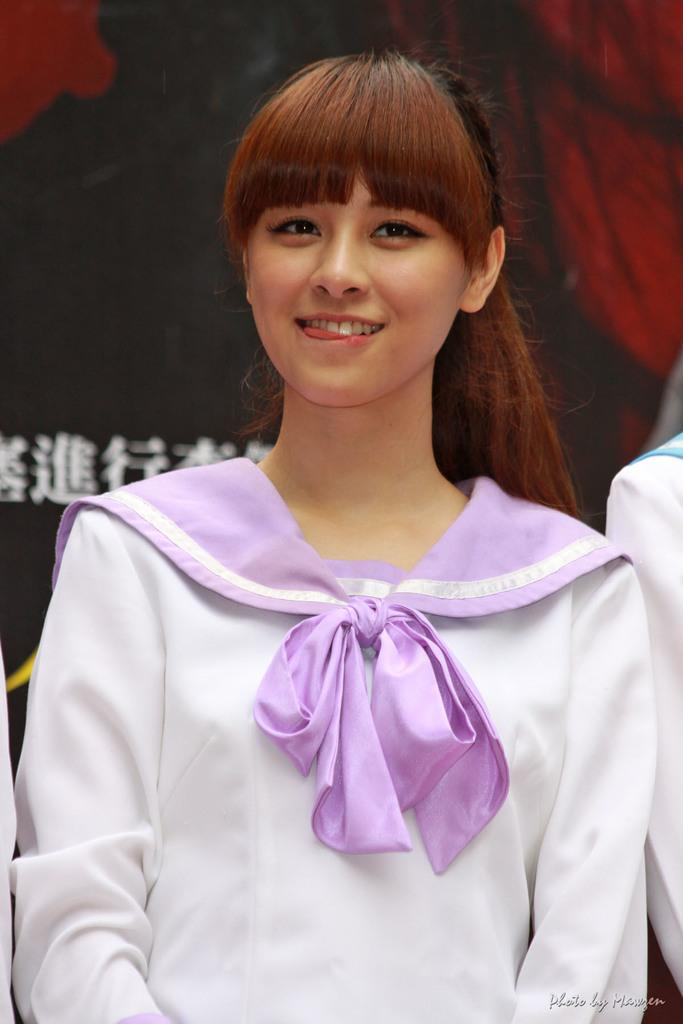Who is the main subject in the image? There is a girl in the image. What is the girl wearing on her upper body? The girl is wearing a white shirt. What accessory is the girl wearing around her neck? The girl is wearing a purple scarf. Whose hand is visible beside the girl? A person's hand is visible beside the girl. What can be seen in the background of the image? There is a banner in the background of the image. What type of glove is the girl wearing in the image? There is no glove visible in the image; the girl is wearing a white shirt and a purple scarf. What is the girl saying in the image? The image does not show the girl's mouth or any speech, so it cannot be determined what she might be saying. 